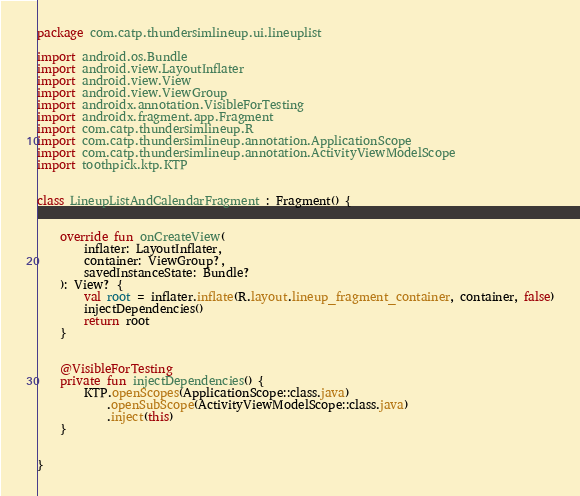Convert code to text. <code><loc_0><loc_0><loc_500><loc_500><_Kotlin_>package com.catp.thundersimlineup.ui.lineuplist

import android.os.Bundle
import android.view.LayoutInflater
import android.view.View
import android.view.ViewGroup
import androidx.annotation.VisibleForTesting
import androidx.fragment.app.Fragment
import com.catp.thundersimlineup.R
import com.catp.thundersimlineup.annotation.ApplicationScope
import com.catp.thundersimlineup.annotation.ActivityViewModelScope
import toothpick.ktp.KTP


class LineupListAndCalendarFragment : Fragment() {


    override fun onCreateView(
        inflater: LayoutInflater,
        container: ViewGroup?,
        savedInstanceState: Bundle?
    ): View? {
        val root = inflater.inflate(R.layout.lineup_fragment_container, container, false)
        injectDependencies()
        return root
    }


    @VisibleForTesting
    private fun injectDependencies() {
        KTP.openScopes(ApplicationScope::class.java)
            .openSubScope(ActivityViewModelScope::class.java)
            .inject(this)
    }


}
</code> 